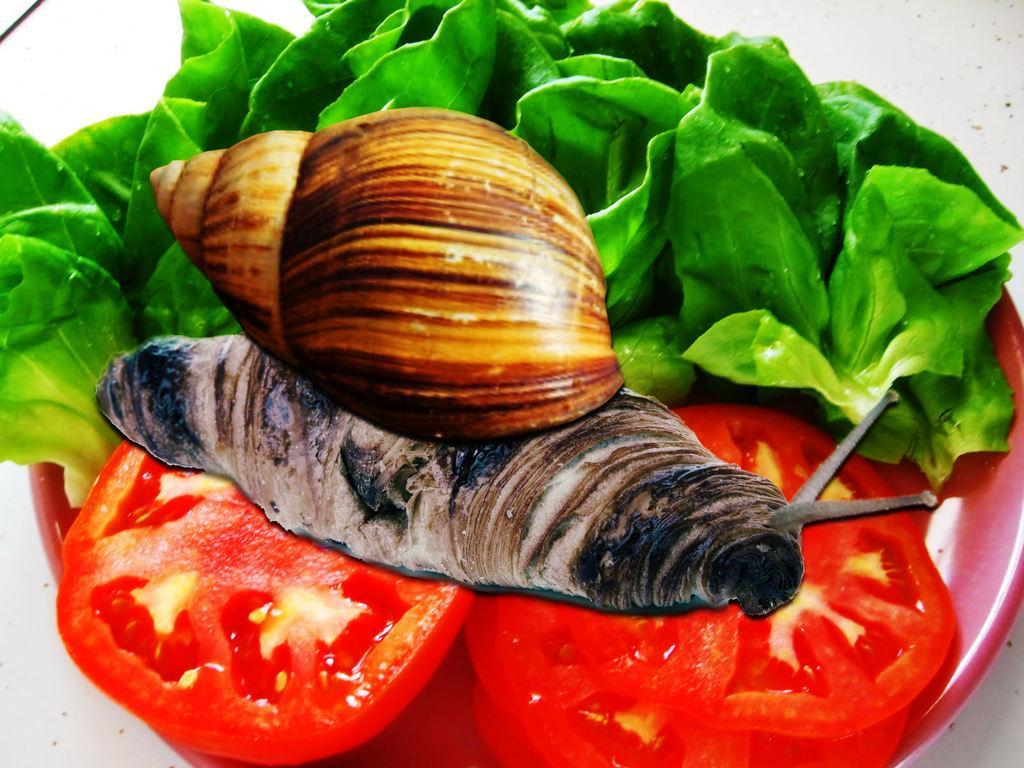Can you describe this image briefly? In this picture, we see a red color bowl or the plate in which tomatoes and leafy vegetable are placed. We even see a shell and a snail. In the background, it is white in color. This picture might be an edited image. 